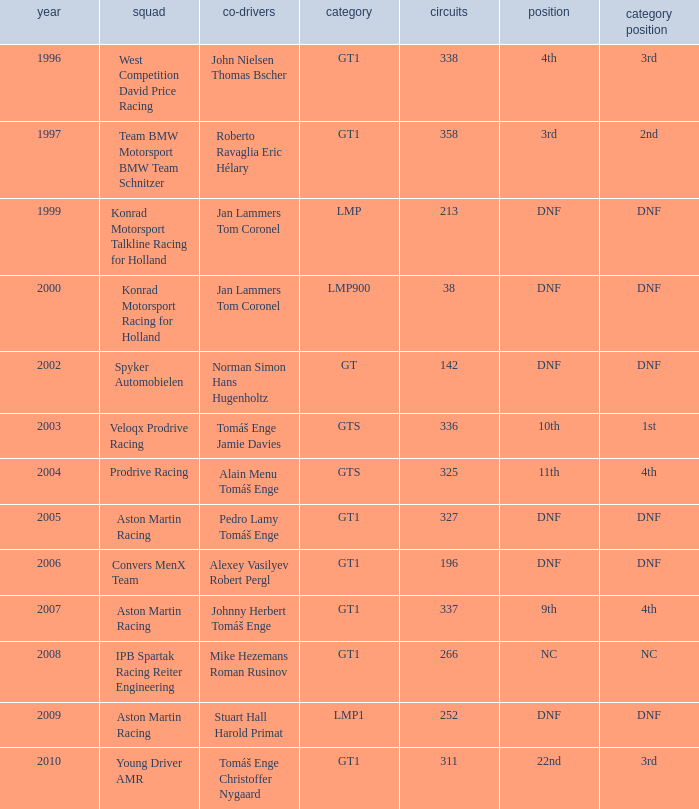In which class had 252 laps and a position of dnf? LMP1. 